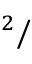Convert formula to latex. <formula><loc_0><loc_0><loc_500><loc_500>^ { 2 } /</formula> 